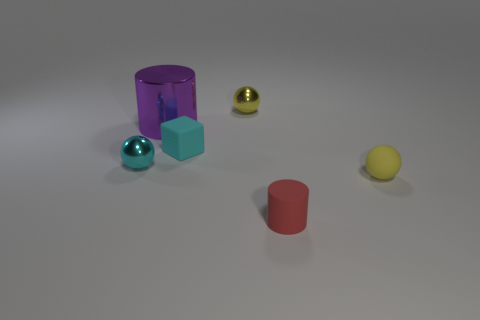There is a yellow object that is on the left side of the yellow sphere in front of the metallic object in front of the large purple cylinder; what is it made of?
Provide a succinct answer. Metal. Is the small block the same color as the large object?
Your answer should be very brief. No. Are there any rubber spheres that have the same color as the small cylinder?
Your answer should be very brief. No. There is a yellow rubber thing that is the same size as the cyan cube; what is its shape?
Make the answer very short. Sphere. Are there fewer big blue matte cylinders than red rubber cylinders?
Offer a terse response. Yes. What number of matte blocks have the same size as the purple cylinder?
Provide a succinct answer. 0. The tiny thing that is the same color as the tiny cube is what shape?
Your response must be concise. Sphere. What material is the big purple object?
Your answer should be compact. Metal. There is a yellow sphere left of the tiny red cylinder; what size is it?
Your response must be concise. Small. How many big purple shiny things are the same shape as the tiny cyan rubber object?
Offer a very short reply. 0. 